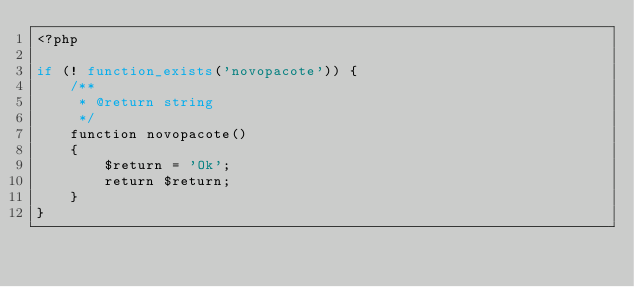Convert code to text. <code><loc_0><loc_0><loc_500><loc_500><_PHP_><?php

if (! function_exists('novopacote')) {
    /**
     * @return string
     */
    function novopacote()
    {
        $return = 'Ok';
        return $return;
    }
}
</code> 